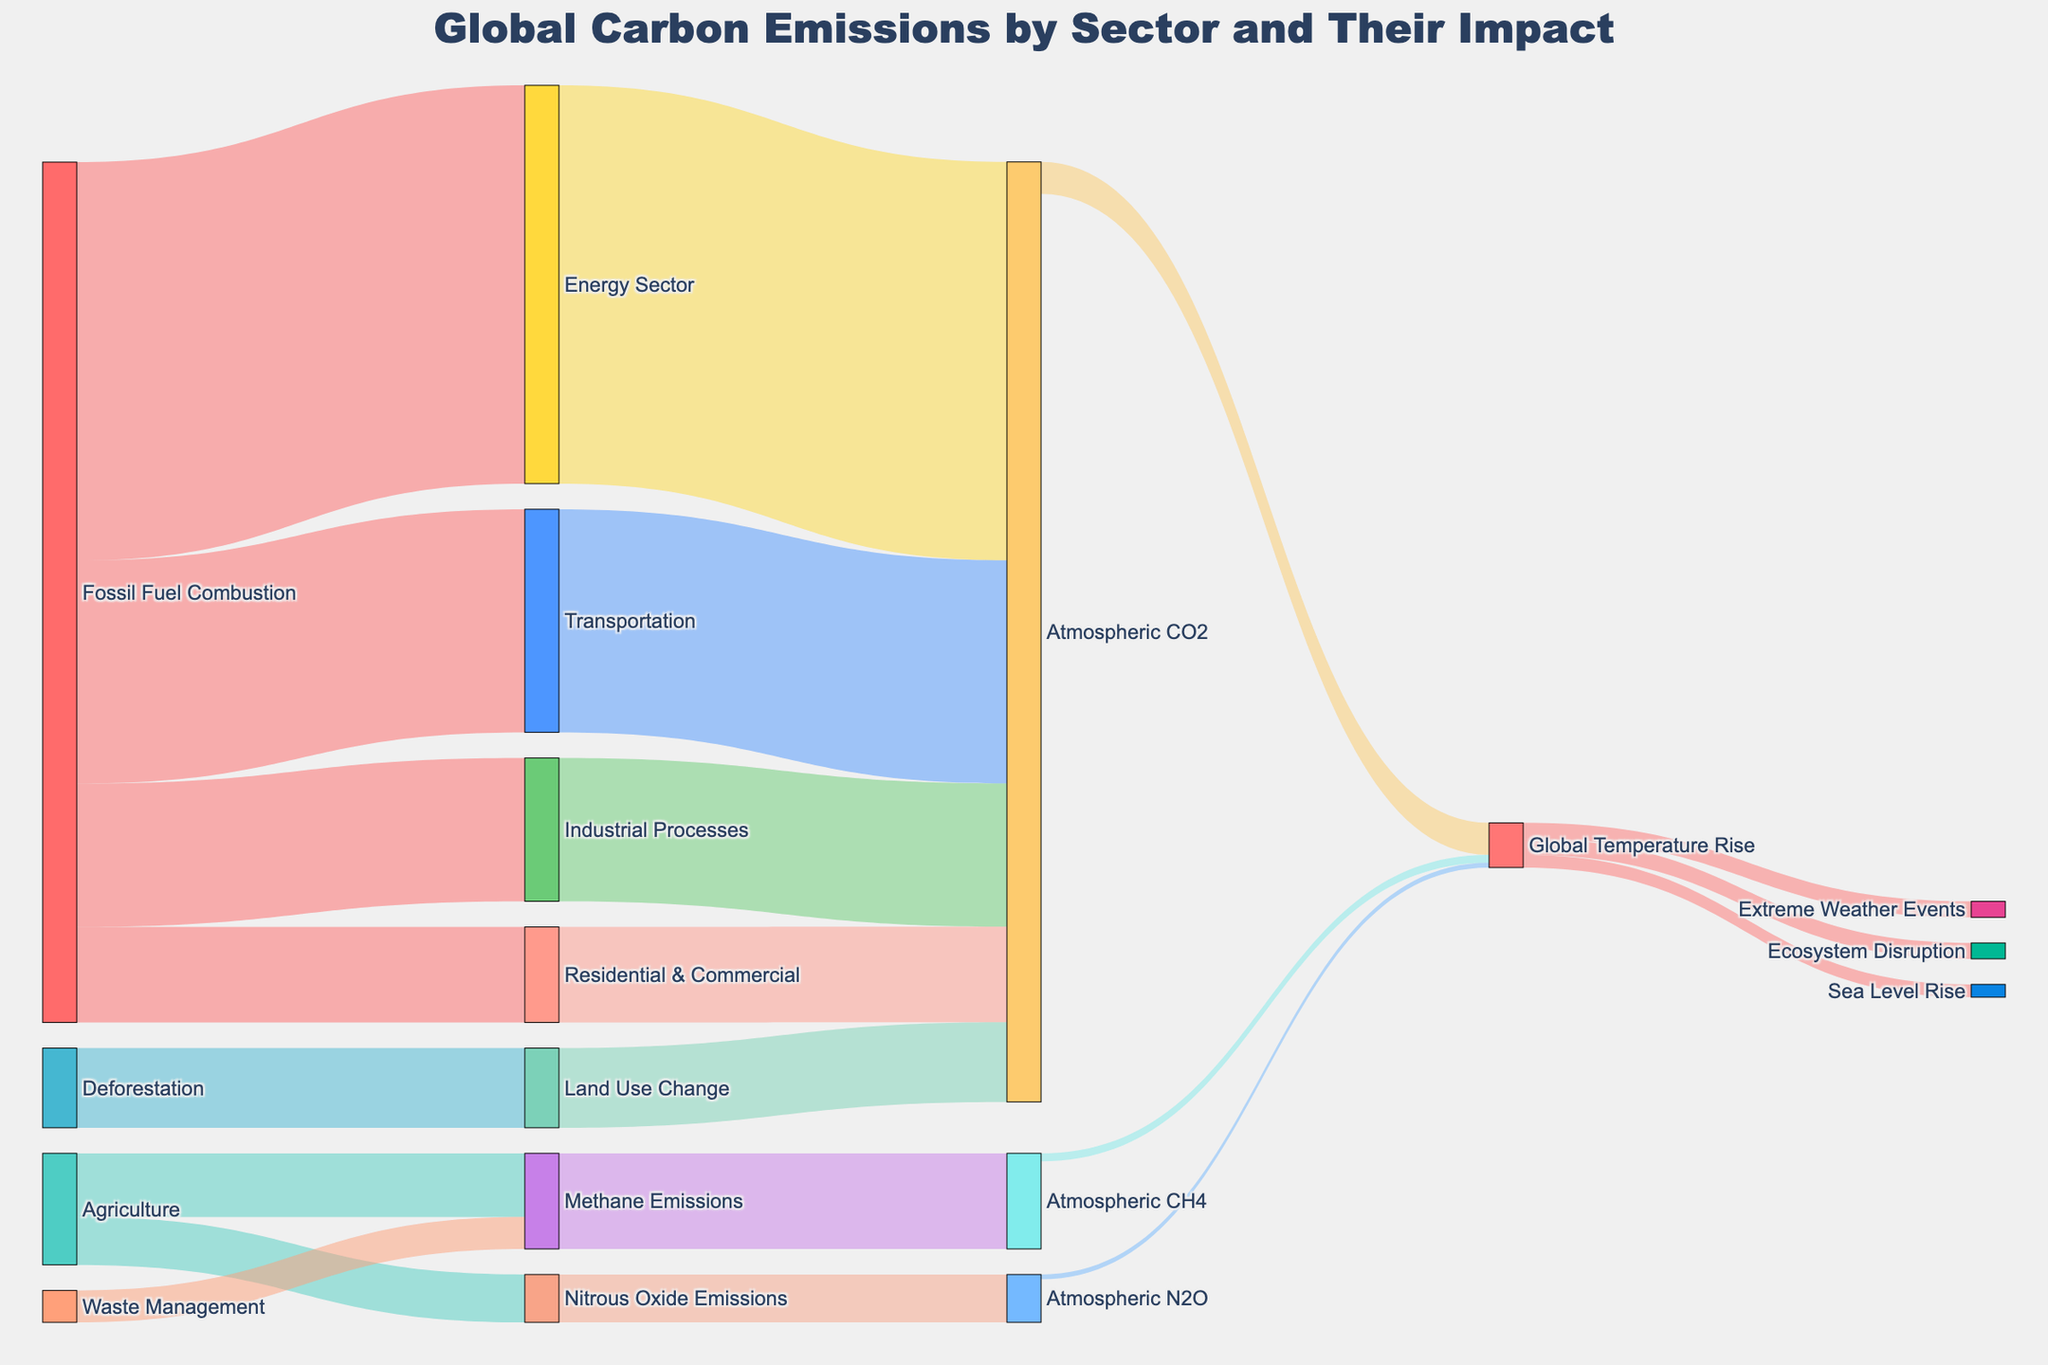What sector contributes the most to atmospheric CO2 emissions? Referring to the Sankey diagram, the Energy Sector has a flow of 25 units leading directly to Atmospheric CO2, which is the largest contribution compared to other sectors.
Answer: Energy Sector What is the combined impact of Methane Emissions from Agriculture and Waste Management on Atmospheric CH4? Methane Emissions from Agriculture leads to 4 units and Waste Management leads to 2 units for a total impact of 4 + 2 = 6 units on Atmospheric CH4.
Answer: 6 units How much does Deforestation and Land Use Change together contribute to Atmospheric CO2? Deforestation leads to Land Use Change with 5 units, then Land Use Change contributes 5 units to Atmospheric CO2. So, the total from Deforestation and Land Use Change is 5 units.
Answer: 5 units Which sectors contribute to the Global Temperature Rise due to Atmospheric CO2? The flows indicate Atmospheric CO2 leads to Global Temperature Rise through sources such as the Energy Sector, Industrial Processes, Transportation, Residential & Commercial, and Land Use Change. Specifically, each of these flows into Atmospheric CO2 which then links to Global Temperature Rise.
Answer: Energy Sector, Industrial Processes, Transportation, Residential & Commercial, Land Use Change What is the total contribution of fossil fuel combustion in terms of CO2 emissions? Summing up the contributions of fossil fuel combustion to various sectors: Energy Sector (25 units), Industrial Processes (9 units), Transportation (14 units), Residential & Commercial (6 units), we get a total of 25 + 9 + 14 + 6 = 54 units.
Answer: 54 units What percentage of the Global Temperature Rise is attributed to Atmospheric CH4? The total value for Global Temperature Rise is the sum of flows from Atmospheric CO2 (2 units), Atmospheric CH4 (0.5 units), and Atmospheric N2O (0.3 units), which sums up to 2.8 units. Atmospheric CH4's contribution is 0.5 units out of this total. Calculating the percentage: (0.5 / 2.8) * 100% ≈ 17.86%.
Answer: 17.86% How do the impacts of Global Temperature Rise distribute across different consequences? Global Temperature Rise impacts Sea Level Rise (0.8 units), Extreme Weather Events (1.0 unit), and Ecosystem Disruption (1.0 unit). The total of these impacts is 0.8 + 1.0 + 1.0 = 2.8 units. Each consequence: Sea Level Rise (0.8/2.8), Extreme Weather Events (1.0/2.8), Ecosystem Disruption (1.0/2.8).
Answer: Sea Level Rise: 28.57%, Extreme Weather Events: 35.71%, Ecosystem Disruption: 35.71% Which emission type from Agriculture has a greater impact on Global Temperature Rise? Methane Emissions (4 units) and Nitrous Oxide Emissions (3 units) from Agriculture flow to Methane Emissions and Nitrous Oxide Emissions respectively. Methane Emissions contributes 0.5 units and Nitrous Oxide Emissions contributes 0.3 units to Global Temperature Rise. Methane Emissions has a greater impact.
Answer: Methane Emissions What is the total value flowing into 'Global Temperature Rise'? Adding the values of flows into 'Global Temperature Rise' from Atmospheric CO2 (2.0 units), Atmospheric CH4 (0.5 units), and Atmospheric N2O (0.3 units): 2 + 0.5 + 0.3 = 2.8 units.
Answer: 2.8 units 